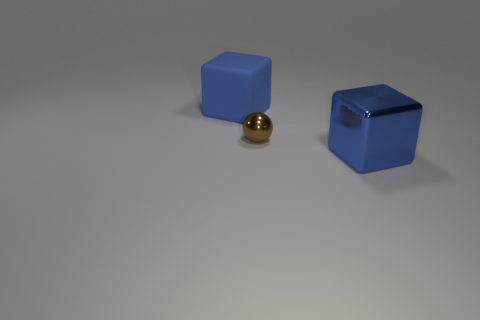Add 3 big blue shiny objects. How many objects exist? 6 Subtract all blocks. How many objects are left? 1 Subtract all large metal blocks. Subtract all tiny brown metal objects. How many objects are left? 1 Add 2 big blue rubber things. How many big blue rubber things are left? 3 Add 1 small brown spheres. How many small brown spheres exist? 2 Subtract 0 blue spheres. How many objects are left? 3 